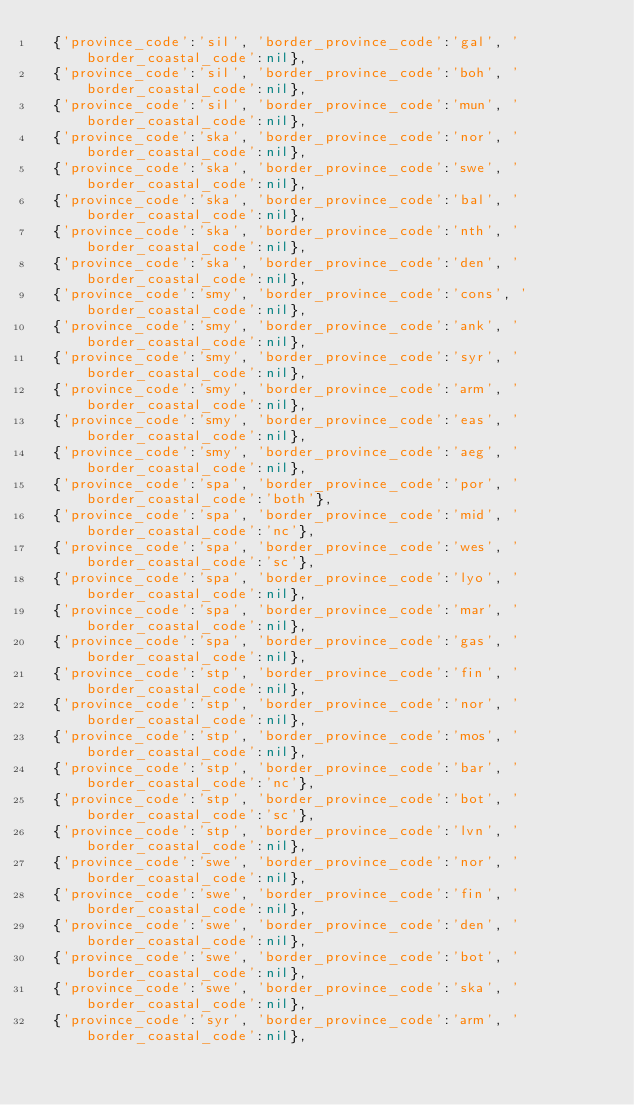Convert code to text. <code><loc_0><loc_0><loc_500><loc_500><_Ruby_>  {'province_code':'sil', 'border_province_code':'gal', 'border_coastal_code':nil},
  {'province_code':'sil', 'border_province_code':'boh', 'border_coastal_code':nil},
  {'province_code':'sil', 'border_province_code':'mun', 'border_coastal_code':nil},
  {'province_code':'ska', 'border_province_code':'nor', 'border_coastal_code':nil},
  {'province_code':'ska', 'border_province_code':'swe', 'border_coastal_code':nil},
  {'province_code':'ska', 'border_province_code':'bal', 'border_coastal_code':nil},
  {'province_code':'ska', 'border_province_code':'nth', 'border_coastal_code':nil},
  {'province_code':'ska', 'border_province_code':'den', 'border_coastal_code':nil},
  {'province_code':'smy', 'border_province_code':'cons', 'border_coastal_code':nil},
  {'province_code':'smy', 'border_province_code':'ank', 'border_coastal_code':nil},
  {'province_code':'smy', 'border_province_code':'syr', 'border_coastal_code':nil},
  {'province_code':'smy', 'border_province_code':'arm', 'border_coastal_code':nil},
  {'province_code':'smy', 'border_province_code':'eas', 'border_coastal_code':nil},
  {'province_code':'smy', 'border_province_code':'aeg', 'border_coastal_code':nil},
  {'province_code':'spa', 'border_province_code':'por', 'border_coastal_code':'both'},
  {'province_code':'spa', 'border_province_code':'mid', 'border_coastal_code':'nc'},
  {'province_code':'spa', 'border_province_code':'wes', 'border_coastal_code':'sc'},
  {'province_code':'spa', 'border_province_code':'lyo', 'border_coastal_code':nil},
  {'province_code':'spa', 'border_province_code':'mar', 'border_coastal_code':nil},
  {'province_code':'spa', 'border_province_code':'gas', 'border_coastal_code':nil},
  {'province_code':'stp', 'border_province_code':'fin', 'border_coastal_code':nil},
  {'province_code':'stp', 'border_province_code':'nor', 'border_coastal_code':nil},
  {'province_code':'stp', 'border_province_code':'mos', 'border_coastal_code':nil},
  {'province_code':'stp', 'border_province_code':'bar', 'border_coastal_code':'nc'},
  {'province_code':'stp', 'border_province_code':'bot', 'border_coastal_code':'sc'},
  {'province_code':'stp', 'border_province_code':'lvn', 'border_coastal_code':nil},
  {'province_code':'swe', 'border_province_code':'nor', 'border_coastal_code':nil},
  {'province_code':'swe', 'border_province_code':'fin', 'border_coastal_code':nil},
  {'province_code':'swe', 'border_province_code':'den', 'border_coastal_code':nil},
  {'province_code':'swe', 'border_province_code':'bot', 'border_coastal_code':nil},
  {'province_code':'swe', 'border_province_code':'ska', 'border_coastal_code':nil},
  {'province_code':'syr', 'border_province_code':'arm', 'border_coastal_code':nil},</code> 